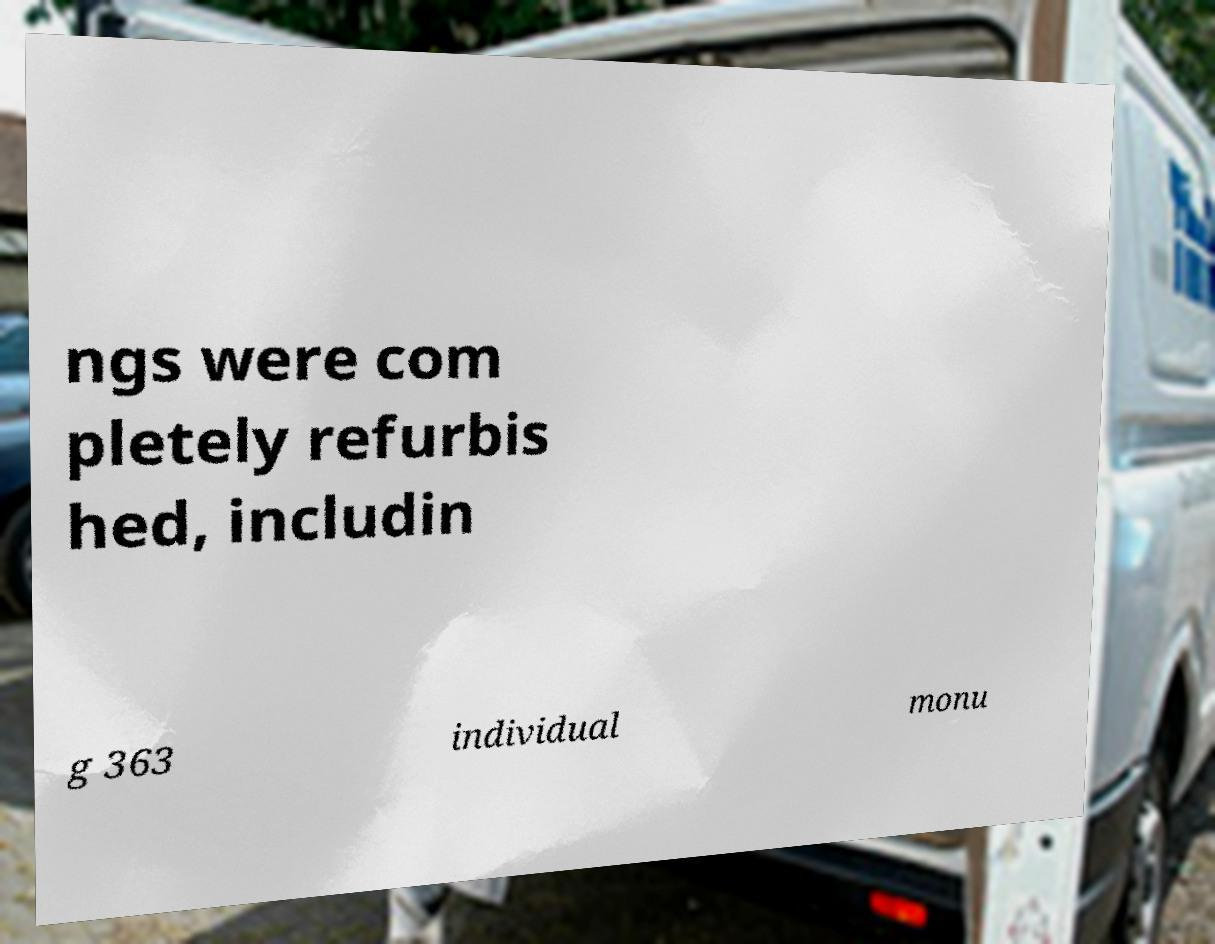Can you read and provide the text displayed in the image?This photo seems to have some interesting text. Can you extract and type it out for me? ngs were com pletely refurbis hed, includin g 363 individual monu 